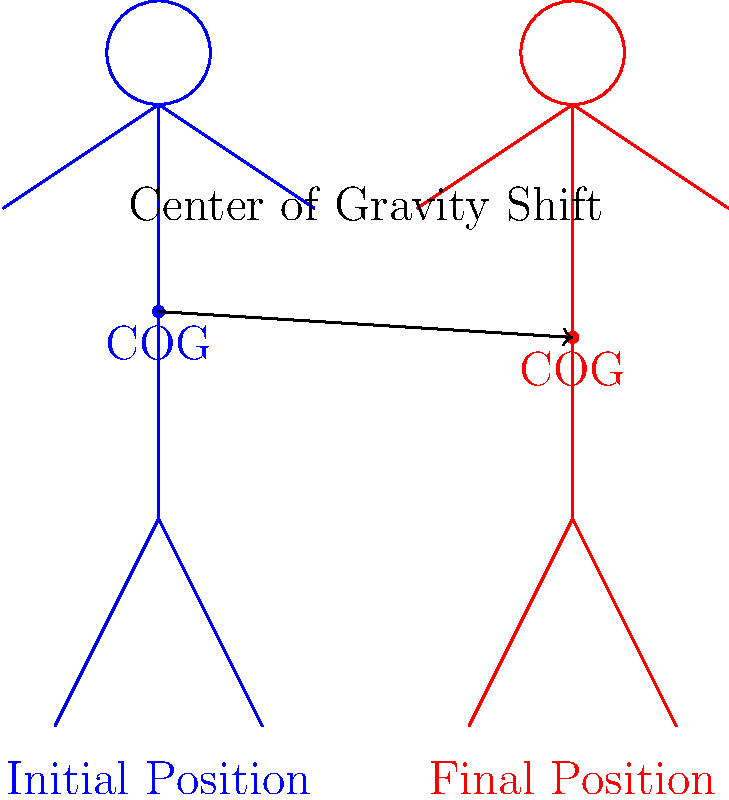During a tai chi form movement, your center of gravity shifts from one position to another. In the diagram, the blue figure shows your initial position, and the red figure shows your final position. How does this movement affect your balance and stability? Let's break down the concept of center of gravity shift in tai chi:

1. Center of Gravity (COG): This is the point where all of your body weight is concentrated.

2. Initial position (blue figure):
   - Your COG is higher and centered in your body.
   - This position is stable but less grounded.

3. Final position (red figure):
   - Your COG has moved lower and slightly forward.
   - This change happens as you shift your weight and lower your stance.

4. Effects on balance and stability:
   - Lower COG: When your COG is lower, you're closer to the ground. This makes you more stable because it's harder to tip you over.
   - Forward shift: Moving your COG forward helps you prepare for the next movement, making your transitions smoother.

5. Tai chi principle:
   - Tai chi emphasizes smooth, controlled movements that shift your weight and COG gradually.
   - This helps improve your balance, coordination, and body awareness.

6. Practical application:
   - By lowering your COG, you create a more stable base for performing martial arts techniques.
   - The forward shift prepares you for advancing movements or strikes.

In conclusion, this COG shift improves your balance and stability by lowering your body's weight center and preparing you for fluid movement sequences.
Answer: The movement lowers and shifts the center of gravity forward, improving balance and stability. 